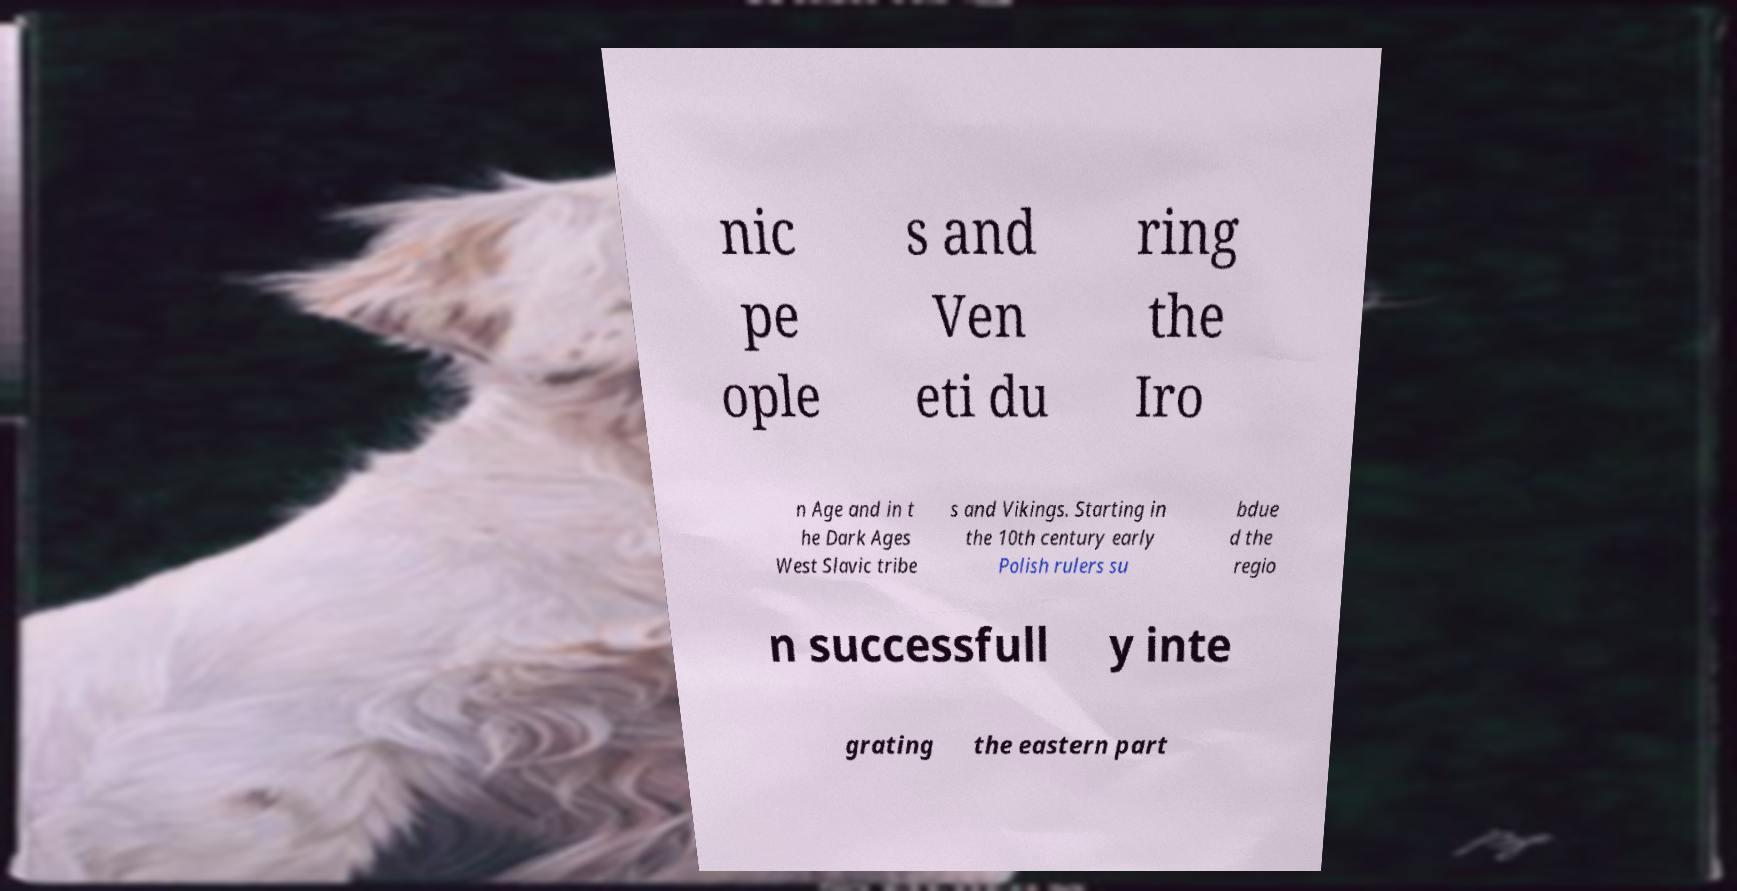Can you read and provide the text displayed in the image?This photo seems to have some interesting text. Can you extract and type it out for me? nic pe ople s and Ven eti du ring the Iro n Age and in t he Dark Ages West Slavic tribe s and Vikings. Starting in the 10th century early Polish rulers su bdue d the regio n successfull y inte grating the eastern part 